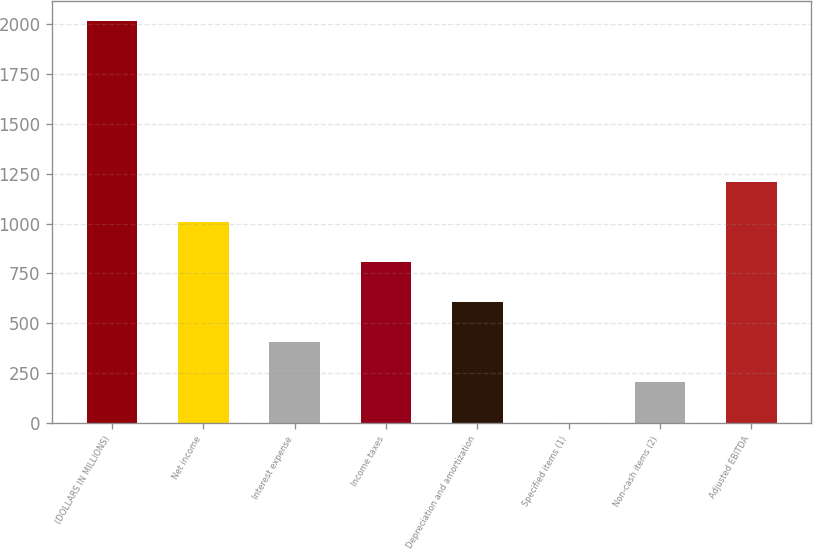Convert chart. <chart><loc_0><loc_0><loc_500><loc_500><bar_chart><fcel>(DOLLARS IN MILLIONS)<fcel>Net income<fcel>Interest expense<fcel>Income taxes<fcel>Depreciation and amortization<fcel>Specified items (1)<fcel>Non-cash items (2)<fcel>Adjusted EBITDA<nl><fcel>2014<fcel>1007.65<fcel>403.84<fcel>806.38<fcel>605.11<fcel>1.3<fcel>202.57<fcel>1208.92<nl></chart> 